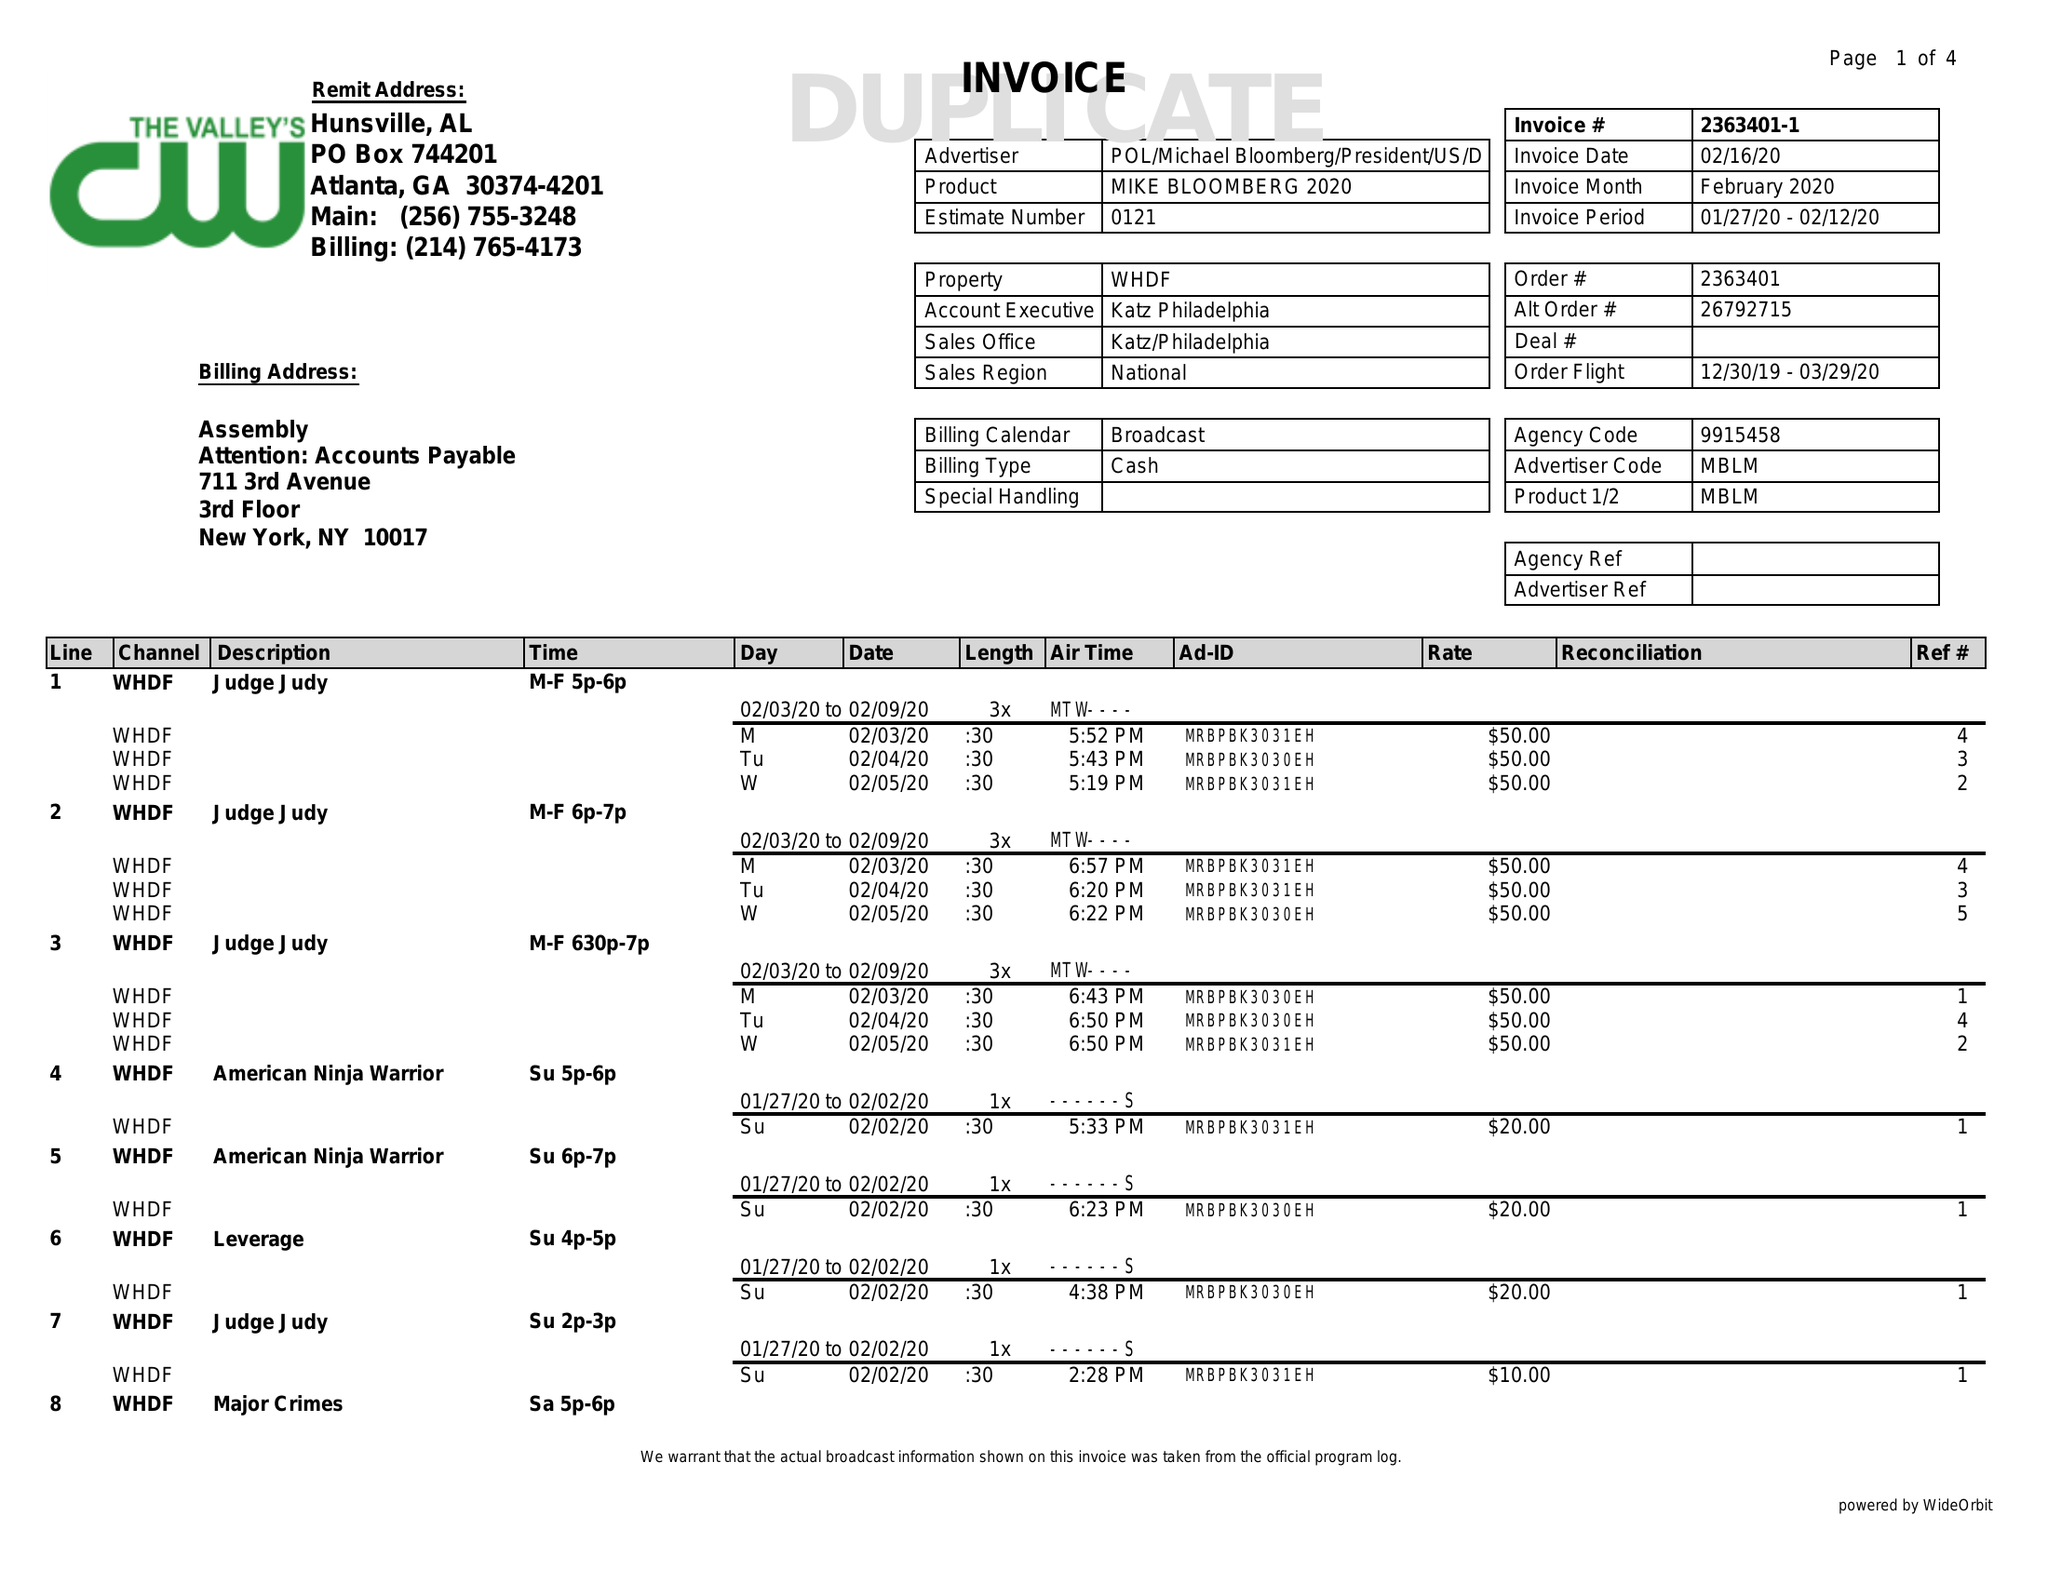What is the value for the flight_to?
Answer the question using a single word or phrase. 03/29/20 